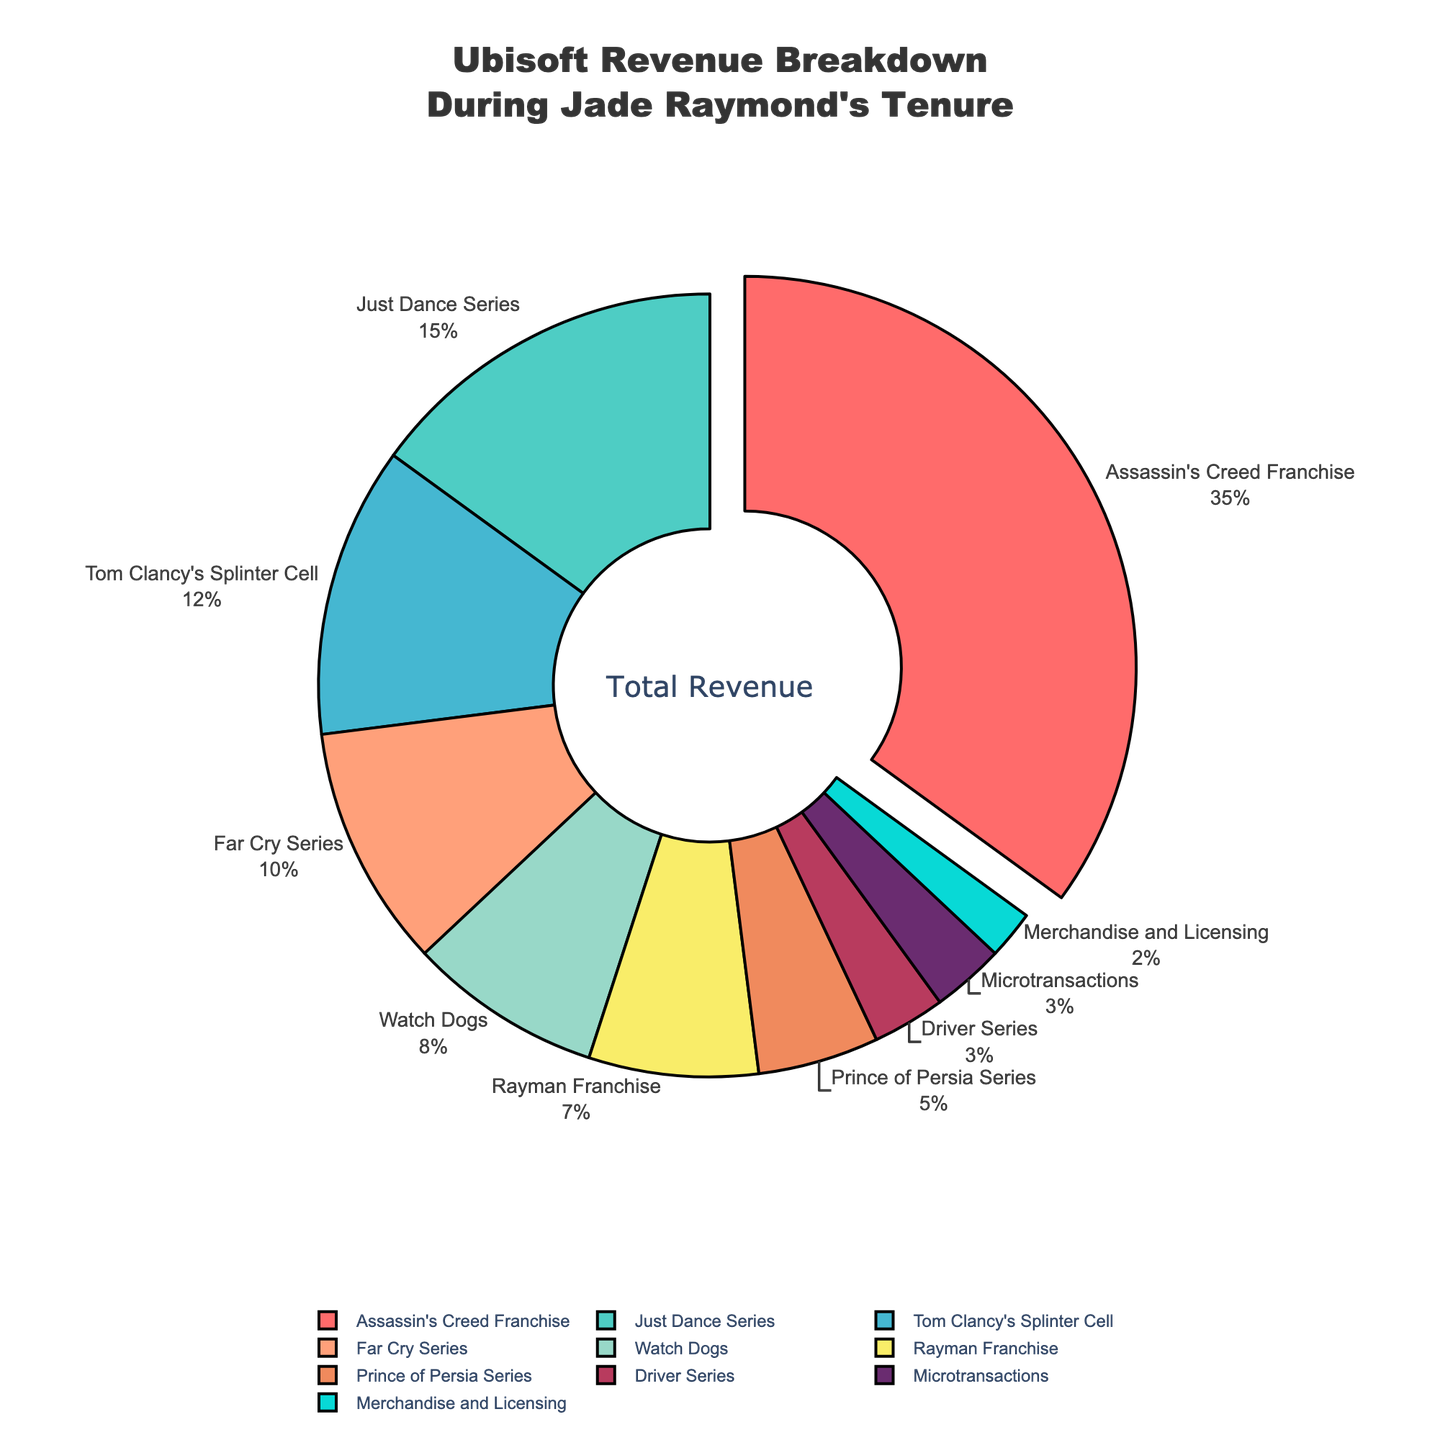What percentage of Ubisoft's revenue comes from the Assassin's Creed Franchise? The pie chart shows various revenue sources with their respective percentages. The Assassin's Creed Franchise slice has a label next to it indicating it accounts for 35% of the revenue.
Answer: 35% What is the difference in revenue percentage between the Just Dance Series and Watch Dogs? According to the pie chart, the Just Dance Series accounts for 15% of the revenue, while Watch Dogs accounts for 8%. Subtract the smaller percentage from the larger percentage: 15% - 8% = 7%.
Answer: 7% Which revenue source contributes the least to Ubisoft's revenue, and what is its percentage? By examining the pie chart, Merchandise and Licensing is labeled as the smallest slice and its percentage is 2%.
Answer: Merchandise and Licensing, 2% How much more revenue (in percentage) does the Assassin's Creed Franchise generate compared to the Far Cry Series? According to the chart, the Assassin's Creed Franchise accounts for 35% and the Far Cry Series accounts for 10%. The difference is 35% - 10% = 25%.
Answer: 25% What is the combined revenue percentage from the Rayman Franchise and the Prince of Persia Series? The pie chart shows the Rayman Franchise at 7% and the Prince of Persia Series at 5%. Adding these two percentages: 7% + 5% = 12%.
Answer: 12% Identify the top three revenue sources. The pie chart segments with the highest percentages are labeled accordingly. The top three sources are Assassin's Creed Franchise (35%), Just Dance Series (15%), and Tom Clancy's Splinter Cell (12%).
Answer: Assassin's Creed Franchise, Just Dance Series, Tom Clancy's Splinter Cell Is the percentage of revenue from microtransactions greater than or less than that from the Driver Series? The pie chart indicates that the revenue from microtransactions is 3%, while the revenue from the Driver Series is also 3%. Therefore, they are equal.
Answer: Equal Which series has nearly double the revenue percentage of the Rayman Franchise, and what is the exact percentage? The Rayman Franchise accounts for 7% of the revenue. The series nearly doubling this would be around 14%. The Just Dance Series is closest with 15%.
Answer: Just Dance Series, 15% If we exclude the top revenue source, what is the total revenue percentage for the remaining sources? The top revenue source is the Assassin's Creed Franchise at 35%. Excluding this, add up the remaining slices: 15% (Just Dance) + 12% (Splinter Cell) + 10% (Far Cry) + 8% (Watch Dogs) + 7% (Rayman) + 5% (Prince of Persia) + 3% (Driver) + 3% (Microtransactions) + 2% (Merchandise and Licensing) = 65%.
Answer: 65% Compare the combined revenue percentages of the Watch Dogs and Rayman Franchise against the combined percentages of the Prince of Persia Series and Driver Series. Which combination contributes more to the total revenue? The Watch Dogs (8%) + Rayman Franchise (7%) = 15%. The Prince of Persia Series (5%) + Driver Series (3%) = 8%. The Watch Dogs and Rayman Franchise combination contributes more to the total revenue.
Answer: Watch Dogs and Rayman Franchise 